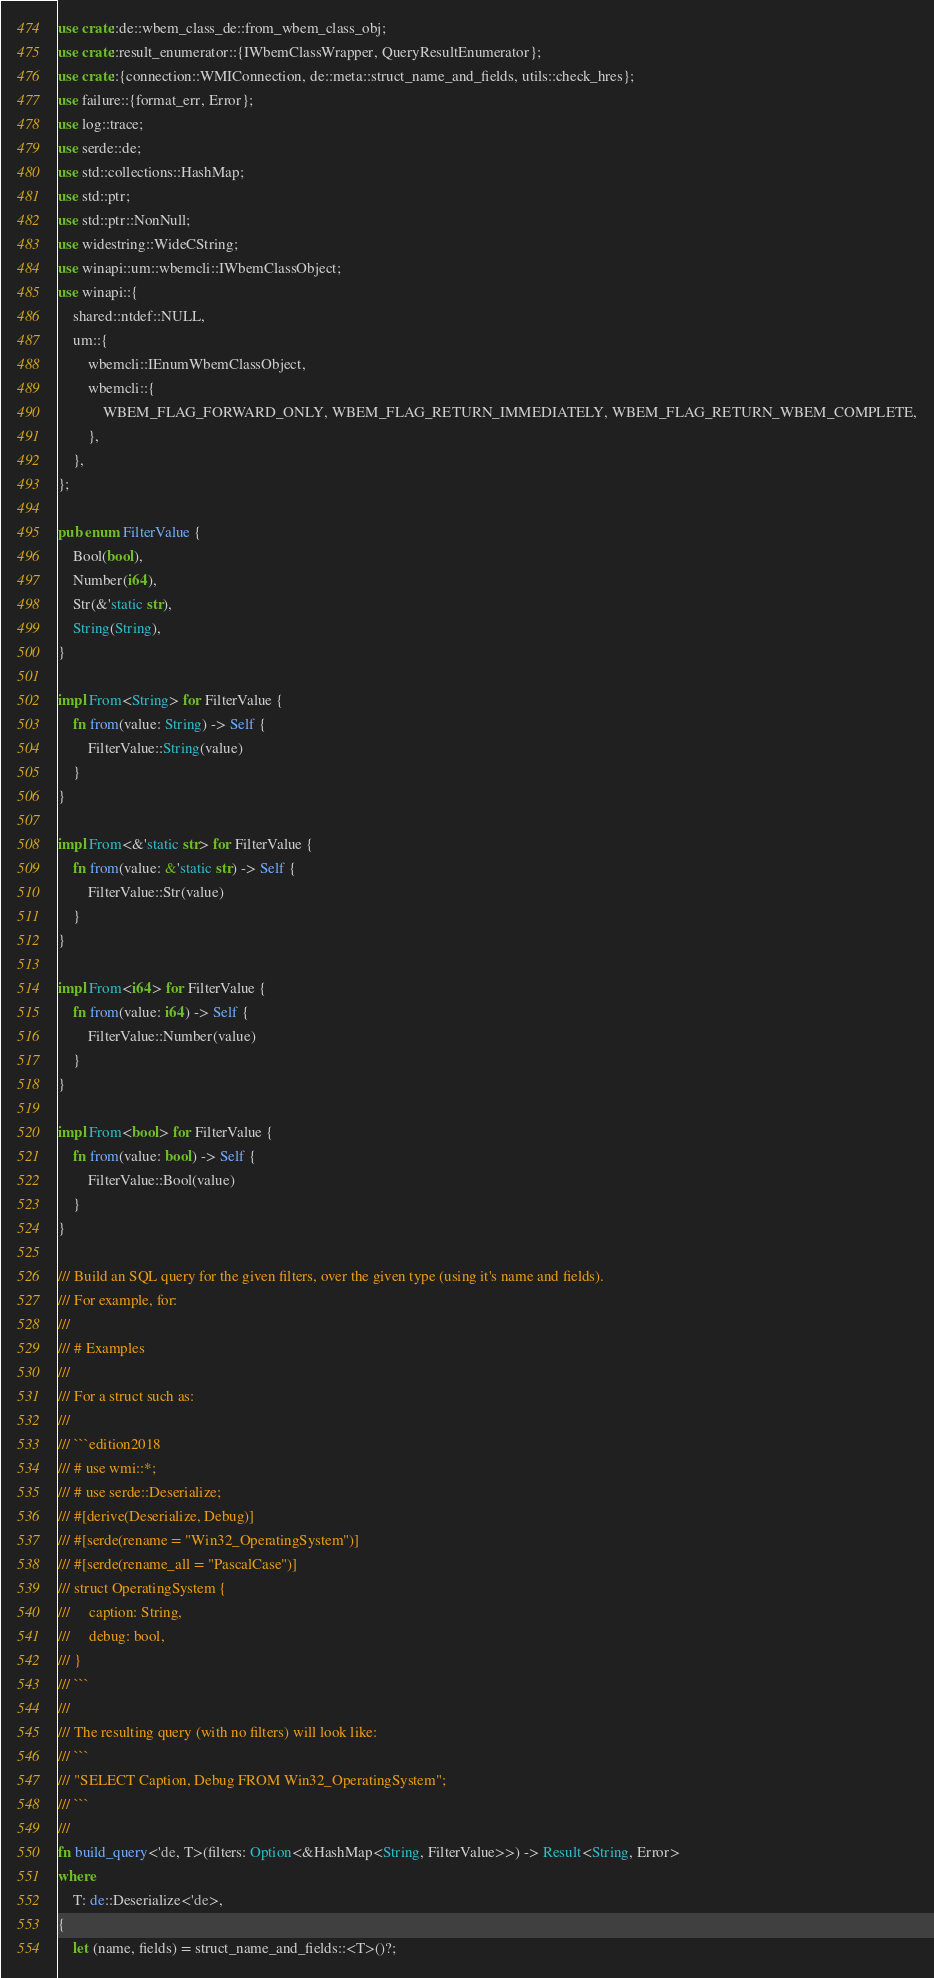Convert code to text. <code><loc_0><loc_0><loc_500><loc_500><_Rust_>use crate::de::wbem_class_de::from_wbem_class_obj;
use crate::result_enumerator::{IWbemClassWrapper, QueryResultEnumerator};
use crate::{connection::WMIConnection, de::meta::struct_name_and_fields, utils::check_hres};
use failure::{format_err, Error};
use log::trace;
use serde::de;
use std::collections::HashMap;
use std::ptr;
use std::ptr::NonNull;
use widestring::WideCString;
use winapi::um::wbemcli::IWbemClassObject;
use winapi::{
    shared::ntdef::NULL,
    um::{
        wbemcli::IEnumWbemClassObject,
        wbemcli::{
            WBEM_FLAG_FORWARD_ONLY, WBEM_FLAG_RETURN_IMMEDIATELY, WBEM_FLAG_RETURN_WBEM_COMPLETE,
        },
    },
};

pub enum FilterValue {
    Bool(bool),
    Number(i64),
    Str(&'static str),
    String(String),
}

impl From<String> for FilterValue {
    fn from(value: String) -> Self {
        FilterValue::String(value)
    }
}

impl From<&'static str> for FilterValue {
    fn from(value: &'static str) -> Self {
        FilterValue::Str(value)
    }
}

impl From<i64> for FilterValue {
    fn from(value: i64) -> Self {
        FilterValue::Number(value)
    }
}

impl From<bool> for FilterValue {
    fn from(value: bool) -> Self {
        FilterValue::Bool(value)
    }
}

/// Build an SQL query for the given filters, over the given type (using it's name and fields).
/// For example, for:
///
/// # Examples
///
/// For a struct such as:
///
/// ```edition2018
/// # use wmi::*;
/// # use serde::Deserialize;
/// #[derive(Deserialize, Debug)]
/// #[serde(rename = "Win32_OperatingSystem")]
/// #[serde(rename_all = "PascalCase")]
/// struct OperatingSystem {
///     caption: String,
///     debug: bool,
/// }
/// ```
///
/// The resulting query (with no filters) will look like:
/// ```
/// "SELECT Caption, Debug FROM Win32_OperatingSystem";
/// ```
///
fn build_query<'de, T>(filters: Option<&HashMap<String, FilterValue>>) -> Result<String, Error>
where
    T: de::Deserialize<'de>,
{
    let (name, fields) = struct_name_and_fields::<T>()?;
</code> 